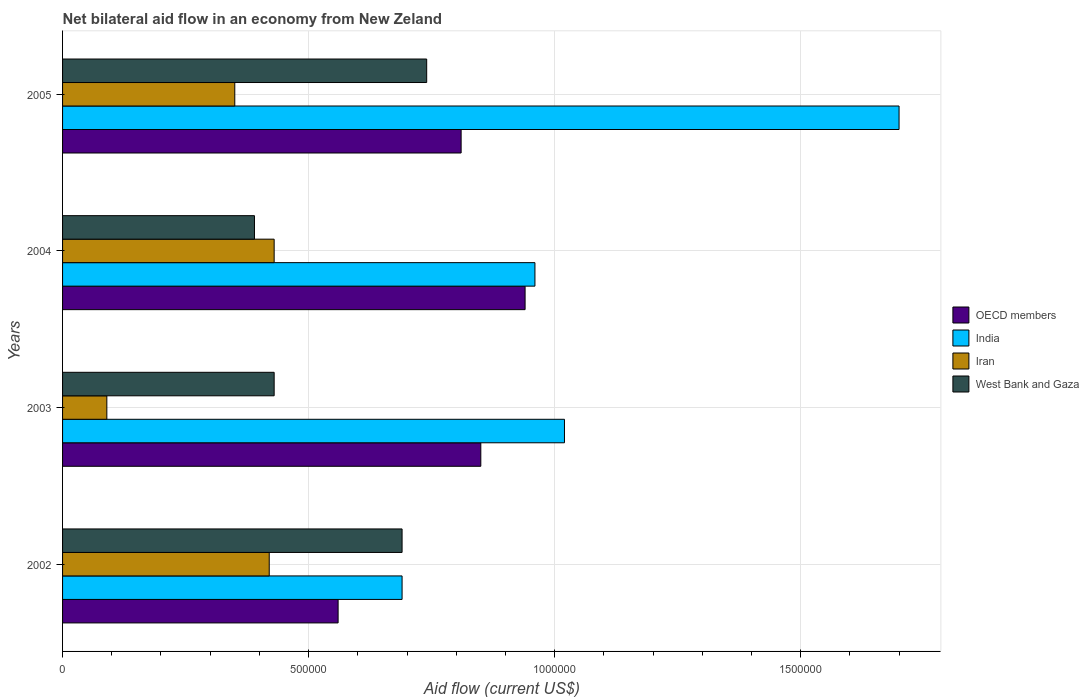Are the number of bars on each tick of the Y-axis equal?
Make the answer very short. Yes. How many bars are there on the 1st tick from the bottom?
Offer a terse response. 4. What is the net bilateral aid flow in West Bank and Gaza in 2002?
Offer a terse response. 6.90e+05. Across all years, what is the maximum net bilateral aid flow in OECD members?
Provide a short and direct response. 9.40e+05. Across all years, what is the minimum net bilateral aid flow in West Bank and Gaza?
Provide a short and direct response. 3.90e+05. In which year was the net bilateral aid flow in OECD members maximum?
Provide a short and direct response. 2004. What is the total net bilateral aid flow in India in the graph?
Ensure brevity in your answer.  4.37e+06. What is the difference between the net bilateral aid flow in OECD members in 2002 and that in 2004?
Your answer should be very brief. -3.80e+05. What is the average net bilateral aid flow in West Bank and Gaza per year?
Offer a terse response. 5.62e+05. Is the net bilateral aid flow in OECD members in 2002 less than that in 2004?
Keep it short and to the point. Yes. Is the difference between the net bilateral aid flow in OECD members in 2002 and 2003 greater than the difference between the net bilateral aid flow in Iran in 2002 and 2003?
Your response must be concise. No. What does the 4th bar from the bottom in 2002 represents?
Provide a succinct answer. West Bank and Gaza. Is it the case that in every year, the sum of the net bilateral aid flow in OECD members and net bilateral aid flow in India is greater than the net bilateral aid flow in West Bank and Gaza?
Ensure brevity in your answer.  Yes. Are all the bars in the graph horizontal?
Give a very brief answer. Yes. How many years are there in the graph?
Offer a very short reply. 4. Are the values on the major ticks of X-axis written in scientific E-notation?
Make the answer very short. No. Does the graph contain grids?
Keep it short and to the point. Yes. How are the legend labels stacked?
Keep it short and to the point. Vertical. What is the title of the graph?
Keep it short and to the point. Net bilateral aid flow in an economy from New Zeland. Does "Bermuda" appear as one of the legend labels in the graph?
Offer a terse response. No. What is the label or title of the X-axis?
Ensure brevity in your answer.  Aid flow (current US$). What is the label or title of the Y-axis?
Provide a short and direct response. Years. What is the Aid flow (current US$) of OECD members in 2002?
Keep it short and to the point. 5.60e+05. What is the Aid flow (current US$) of India in 2002?
Ensure brevity in your answer.  6.90e+05. What is the Aid flow (current US$) of Iran in 2002?
Provide a succinct answer. 4.20e+05. What is the Aid flow (current US$) of West Bank and Gaza in 2002?
Your answer should be compact. 6.90e+05. What is the Aid flow (current US$) in OECD members in 2003?
Your response must be concise. 8.50e+05. What is the Aid flow (current US$) of India in 2003?
Offer a terse response. 1.02e+06. What is the Aid flow (current US$) of Iran in 2003?
Offer a very short reply. 9.00e+04. What is the Aid flow (current US$) in West Bank and Gaza in 2003?
Keep it short and to the point. 4.30e+05. What is the Aid flow (current US$) in OECD members in 2004?
Make the answer very short. 9.40e+05. What is the Aid flow (current US$) in India in 2004?
Provide a succinct answer. 9.60e+05. What is the Aid flow (current US$) of OECD members in 2005?
Give a very brief answer. 8.10e+05. What is the Aid flow (current US$) of India in 2005?
Give a very brief answer. 1.70e+06. What is the Aid flow (current US$) in Iran in 2005?
Your answer should be very brief. 3.50e+05. What is the Aid flow (current US$) in West Bank and Gaza in 2005?
Make the answer very short. 7.40e+05. Across all years, what is the maximum Aid flow (current US$) in OECD members?
Make the answer very short. 9.40e+05. Across all years, what is the maximum Aid flow (current US$) in India?
Provide a short and direct response. 1.70e+06. Across all years, what is the maximum Aid flow (current US$) of West Bank and Gaza?
Offer a very short reply. 7.40e+05. Across all years, what is the minimum Aid flow (current US$) of OECD members?
Ensure brevity in your answer.  5.60e+05. Across all years, what is the minimum Aid flow (current US$) in India?
Offer a very short reply. 6.90e+05. Across all years, what is the minimum Aid flow (current US$) of West Bank and Gaza?
Provide a succinct answer. 3.90e+05. What is the total Aid flow (current US$) of OECD members in the graph?
Give a very brief answer. 3.16e+06. What is the total Aid flow (current US$) of India in the graph?
Ensure brevity in your answer.  4.37e+06. What is the total Aid flow (current US$) in Iran in the graph?
Ensure brevity in your answer.  1.29e+06. What is the total Aid flow (current US$) of West Bank and Gaza in the graph?
Your answer should be compact. 2.25e+06. What is the difference between the Aid flow (current US$) of OECD members in 2002 and that in 2003?
Make the answer very short. -2.90e+05. What is the difference between the Aid flow (current US$) in India in 2002 and that in 2003?
Provide a succinct answer. -3.30e+05. What is the difference between the Aid flow (current US$) of Iran in 2002 and that in 2003?
Provide a short and direct response. 3.30e+05. What is the difference between the Aid flow (current US$) in West Bank and Gaza in 2002 and that in 2003?
Give a very brief answer. 2.60e+05. What is the difference between the Aid flow (current US$) in OECD members in 2002 and that in 2004?
Make the answer very short. -3.80e+05. What is the difference between the Aid flow (current US$) of West Bank and Gaza in 2002 and that in 2004?
Provide a short and direct response. 3.00e+05. What is the difference between the Aid flow (current US$) of OECD members in 2002 and that in 2005?
Ensure brevity in your answer.  -2.50e+05. What is the difference between the Aid flow (current US$) in India in 2002 and that in 2005?
Ensure brevity in your answer.  -1.01e+06. What is the difference between the Aid flow (current US$) in West Bank and Gaza in 2002 and that in 2005?
Provide a succinct answer. -5.00e+04. What is the difference between the Aid flow (current US$) in India in 2003 and that in 2004?
Offer a terse response. 6.00e+04. What is the difference between the Aid flow (current US$) of India in 2003 and that in 2005?
Provide a short and direct response. -6.80e+05. What is the difference between the Aid flow (current US$) in West Bank and Gaza in 2003 and that in 2005?
Provide a short and direct response. -3.10e+05. What is the difference between the Aid flow (current US$) in OECD members in 2004 and that in 2005?
Your response must be concise. 1.30e+05. What is the difference between the Aid flow (current US$) of India in 2004 and that in 2005?
Offer a terse response. -7.40e+05. What is the difference between the Aid flow (current US$) in West Bank and Gaza in 2004 and that in 2005?
Your answer should be very brief. -3.50e+05. What is the difference between the Aid flow (current US$) in OECD members in 2002 and the Aid flow (current US$) in India in 2003?
Offer a very short reply. -4.60e+05. What is the difference between the Aid flow (current US$) of OECD members in 2002 and the Aid flow (current US$) of Iran in 2003?
Offer a very short reply. 4.70e+05. What is the difference between the Aid flow (current US$) of OECD members in 2002 and the Aid flow (current US$) of West Bank and Gaza in 2003?
Offer a terse response. 1.30e+05. What is the difference between the Aid flow (current US$) in India in 2002 and the Aid flow (current US$) in West Bank and Gaza in 2003?
Your response must be concise. 2.60e+05. What is the difference between the Aid flow (current US$) in Iran in 2002 and the Aid flow (current US$) in West Bank and Gaza in 2003?
Ensure brevity in your answer.  -10000. What is the difference between the Aid flow (current US$) of OECD members in 2002 and the Aid flow (current US$) of India in 2004?
Ensure brevity in your answer.  -4.00e+05. What is the difference between the Aid flow (current US$) in OECD members in 2002 and the Aid flow (current US$) in Iran in 2004?
Ensure brevity in your answer.  1.30e+05. What is the difference between the Aid flow (current US$) of India in 2002 and the Aid flow (current US$) of West Bank and Gaza in 2004?
Your response must be concise. 3.00e+05. What is the difference between the Aid flow (current US$) of Iran in 2002 and the Aid flow (current US$) of West Bank and Gaza in 2004?
Provide a succinct answer. 3.00e+04. What is the difference between the Aid flow (current US$) in OECD members in 2002 and the Aid flow (current US$) in India in 2005?
Give a very brief answer. -1.14e+06. What is the difference between the Aid flow (current US$) of OECD members in 2002 and the Aid flow (current US$) of Iran in 2005?
Your answer should be compact. 2.10e+05. What is the difference between the Aid flow (current US$) of India in 2002 and the Aid flow (current US$) of West Bank and Gaza in 2005?
Keep it short and to the point. -5.00e+04. What is the difference between the Aid flow (current US$) of Iran in 2002 and the Aid flow (current US$) of West Bank and Gaza in 2005?
Make the answer very short. -3.20e+05. What is the difference between the Aid flow (current US$) of OECD members in 2003 and the Aid flow (current US$) of India in 2004?
Provide a short and direct response. -1.10e+05. What is the difference between the Aid flow (current US$) in OECD members in 2003 and the Aid flow (current US$) in Iran in 2004?
Provide a short and direct response. 4.20e+05. What is the difference between the Aid flow (current US$) in OECD members in 2003 and the Aid flow (current US$) in West Bank and Gaza in 2004?
Offer a very short reply. 4.60e+05. What is the difference between the Aid flow (current US$) in India in 2003 and the Aid flow (current US$) in Iran in 2004?
Offer a terse response. 5.90e+05. What is the difference between the Aid flow (current US$) of India in 2003 and the Aid flow (current US$) of West Bank and Gaza in 2004?
Provide a succinct answer. 6.30e+05. What is the difference between the Aid flow (current US$) of Iran in 2003 and the Aid flow (current US$) of West Bank and Gaza in 2004?
Offer a very short reply. -3.00e+05. What is the difference between the Aid flow (current US$) in OECD members in 2003 and the Aid flow (current US$) in India in 2005?
Provide a succinct answer. -8.50e+05. What is the difference between the Aid flow (current US$) in OECD members in 2003 and the Aid flow (current US$) in Iran in 2005?
Provide a succinct answer. 5.00e+05. What is the difference between the Aid flow (current US$) of OECD members in 2003 and the Aid flow (current US$) of West Bank and Gaza in 2005?
Make the answer very short. 1.10e+05. What is the difference between the Aid flow (current US$) of India in 2003 and the Aid flow (current US$) of Iran in 2005?
Provide a succinct answer. 6.70e+05. What is the difference between the Aid flow (current US$) in Iran in 2003 and the Aid flow (current US$) in West Bank and Gaza in 2005?
Keep it short and to the point. -6.50e+05. What is the difference between the Aid flow (current US$) of OECD members in 2004 and the Aid flow (current US$) of India in 2005?
Keep it short and to the point. -7.60e+05. What is the difference between the Aid flow (current US$) of OECD members in 2004 and the Aid flow (current US$) of Iran in 2005?
Offer a terse response. 5.90e+05. What is the difference between the Aid flow (current US$) of India in 2004 and the Aid flow (current US$) of West Bank and Gaza in 2005?
Offer a very short reply. 2.20e+05. What is the difference between the Aid flow (current US$) of Iran in 2004 and the Aid flow (current US$) of West Bank and Gaza in 2005?
Provide a succinct answer. -3.10e+05. What is the average Aid flow (current US$) in OECD members per year?
Make the answer very short. 7.90e+05. What is the average Aid flow (current US$) of India per year?
Offer a terse response. 1.09e+06. What is the average Aid flow (current US$) of Iran per year?
Keep it short and to the point. 3.22e+05. What is the average Aid flow (current US$) in West Bank and Gaza per year?
Offer a very short reply. 5.62e+05. In the year 2002, what is the difference between the Aid flow (current US$) of OECD members and Aid flow (current US$) of India?
Provide a short and direct response. -1.30e+05. In the year 2002, what is the difference between the Aid flow (current US$) in India and Aid flow (current US$) in West Bank and Gaza?
Your response must be concise. 0. In the year 2002, what is the difference between the Aid flow (current US$) in Iran and Aid flow (current US$) in West Bank and Gaza?
Make the answer very short. -2.70e+05. In the year 2003, what is the difference between the Aid flow (current US$) in OECD members and Aid flow (current US$) in India?
Your answer should be compact. -1.70e+05. In the year 2003, what is the difference between the Aid flow (current US$) in OECD members and Aid flow (current US$) in Iran?
Provide a succinct answer. 7.60e+05. In the year 2003, what is the difference between the Aid flow (current US$) of India and Aid flow (current US$) of Iran?
Keep it short and to the point. 9.30e+05. In the year 2003, what is the difference between the Aid flow (current US$) of India and Aid flow (current US$) of West Bank and Gaza?
Keep it short and to the point. 5.90e+05. In the year 2004, what is the difference between the Aid flow (current US$) of OECD members and Aid flow (current US$) of Iran?
Your answer should be very brief. 5.10e+05. In the year 2004, what is the difference between the Aid flow (current US$) in OECD members and Aid flow (current US$) in West Bank and Gaza?
Ensure brevity in your answer.  5.50e+05. In the year 2004, what is the difference between the Aid flow (current US$) in India and Aid flow (current US$) in Iran?
Your response must be concise. 5.30e+05. In the year 2004, what is the difference between the Aid flow (current US$) of India and Aid flow (current US$) of West Bank and Gaza?
Make the answer very short. 5.70e+05. In the year 2004, what is the difference between the Aid flow (current US$) of Iran and Aid flow (current US$) of West Bank and Gaza?
Offer a very short reply. 4.00e+04. In the year 2005, what is the difference between the Aid flow (current US$) in OECD members and Aid flow (current US$) in India?
Provide a short and direct response. -8.90e+05. In the year 2005, what is the difference between the Aid flow (current US$) in OECD members and Aid flow (current US$) in Iran?
Give a very brief answer. 4.60e+05. In the year 2005, what is the difference between the Aid flow (current US$) of India and Aid flow (current US$) of Iran?
Ensure brevity in your answer.  1.35e+06. In the year 2005, what is the difference between the Aid flow (current US$) of India and Aid flow (current US$) of West Bank and Gaza?
Provide a succinct answer. 9.60e+05. In the year 2005, what is the difference between the Aid flow (current US$) of Iran and Aid flow (current US$) of West Bank and Gaza?
Your answer should be very brief. -3.90e+05. What is the ratio of the Aid flow (current US$) of OECD members in 2002 to that in 2003?
Keep it short and to the point. 0.66. What is the ratio of the Aid flow (current US$) of India in 2002 to that in 2003?
Make the answer very short. 0.68. What is the ratio of the Aid flow (current US$) in Iran in 2002 to that in 2003?
Make the answer very short. 4.67. What is the ratio of the Aid flow (current US$) of West Bank and Gaza in 2002 to that in 2003?
Your response must be concise. 1.6. What is the ratio of the Aid flow (current US$) in OECD members in 2002 to that in 2004?
Provide a short and direct response. 0.6. What is the ratio of the Aid flow (current US$) in India in 2002 to that in 2004?
Offer a very short reply. 0.72. What is the ratio of the Aid flow (current US$) of Iran in 2002 to that in 2004?
Keep it short and to the point. 0.98. What is the ratio of the Aid flow (current US$) in West Bank and Gaza in 2002 to that in 2004?
Offer a very short reply. 1.77. What is the ratio of the Aid flow (current US$) in OECD members in 2002 to that in 2005?
Your answer should be compact. 0.69. What is the ratio of the Aid flow (current US$) of India in 2002 to that in 2005?
Offer a very short reply. 0.41. What is the ratio of the Aid flow (current US$) in Iran in 2002 to that in 2005?
Your answer should be very brief. 1.2. What is the ratio of the Aid flow (current US$) of West Bank and Gaza in 2002 to that in 2005?
Make the answer very short. 0.93. What is the ratio of the Aid flow (current US$) in OECD members in 2003 to that in 2004?
Your answer should be compact. 0.9. What is the ratio of the Aid flow (current US$) of India in 2003 to that in 2004?
Give a very brief answer. 1.06. What is the ratio of the Aid flow (current US$) of Iran in 2003 to that in 2004?
Make the answer very short. 0.21. What is the ratio of the Aid flow (current US$) in West Bank and Gaza in 2003 to that in 2004?
Keep it short and to the point. 1.1. What is the ratio of the Aid flow (current US$) of OECD members in 2003 to that in 2005?
Your answer should be very brief. 1.05. What is the ratio of the Aid flow (current US$) of Iran in 2003 to that in 2005?
Provide a succinct answer. 0.26. What is the ratio of the Aid flow (current US$) in West Bank and Gaza in 2003 to that in 2005?
Provide a short and direct response. 0.58. What is the ratio of the Aid flow (current US$) in OECD members in 2004 to that in 2005?
Provide a short and direct response. 1.16. What is the ratio of the Aid flow (current US$) of India in 2004 to that in 2005?
Give a very brief answer. 0.56. What is the ratio of the Aid flow (current US$) of Iran in 2004 to that in 2005?
Your response must be concise. 1.23. What is the ratio of the Aid flow (current US$) of West Bank and Gaza in 2004 to that in 2005?
Make the answer very short. 0.53. What is the difference between the highest and the second highest Aid flow (current US$) of India?
Provide a short and direct response. 6.80e+05. What is the difference between the highest and the second highest Aid flow (current US$) in West Bank and Gaza?
Ensure brevity in your answer.  5.00e+04. What is the difference between the highest and the lowest Aid flow (current US$) of OECD members?
Offer a terse response. 3.80e+05. What is the difference between the highest and the lowest Aid flow (current US$) in India?
Offer a very short reply. 1.01e+06. What is the difference between the highest and the lowest Aid flow (current US$) of Iran?
Offer a terse response. 3.40e+05. 